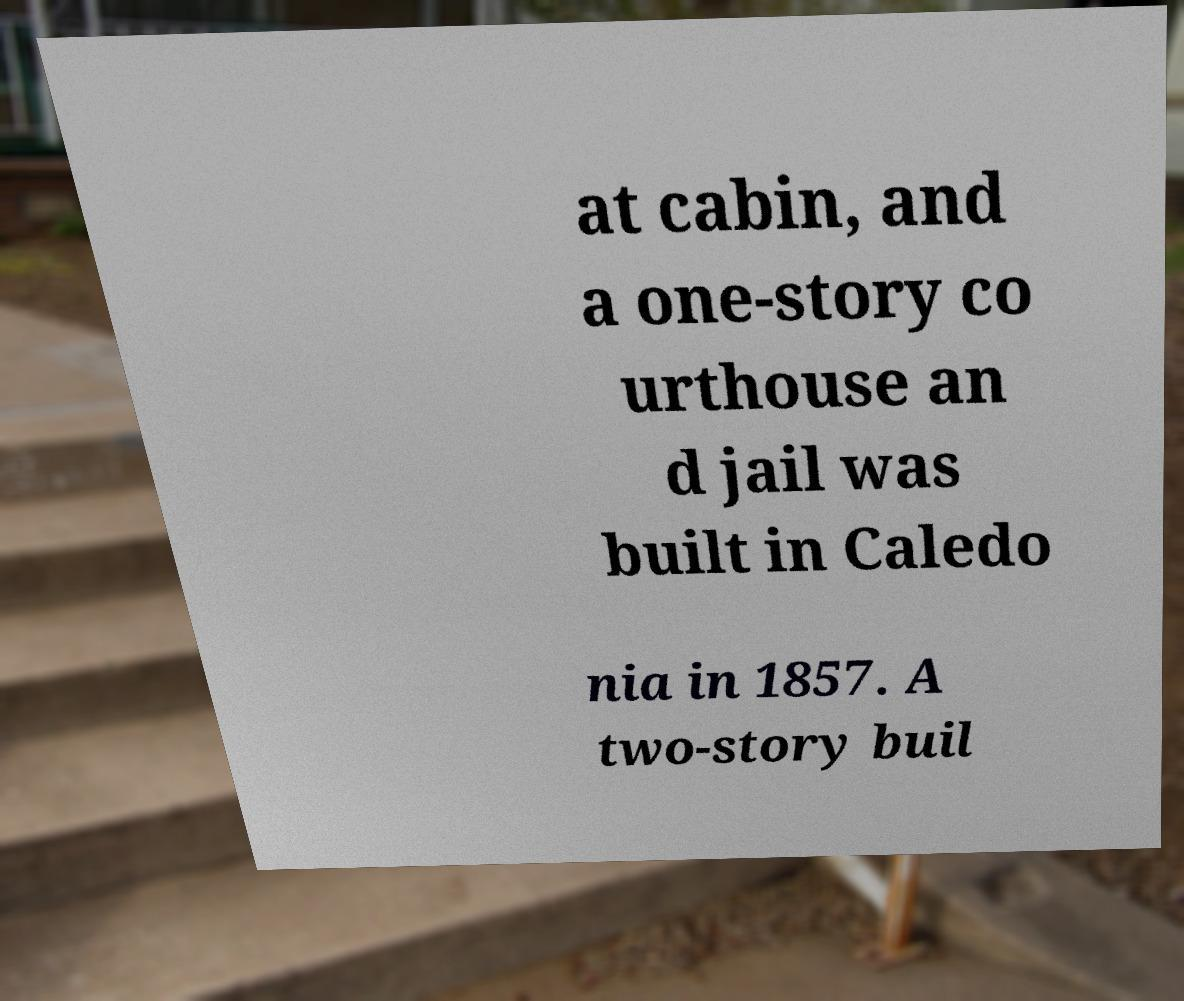Please read and relay the text visible in this image. What does it say? at cabin, and a one-story co urthouse an d jail was built in Caledo nia in 1857. A two-story buil 